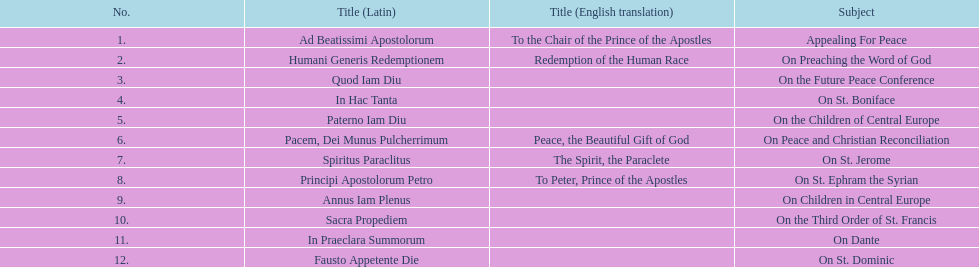Other than january how many encyclicals were in 1921? 2. 